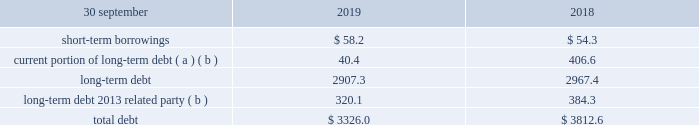During the third quarter ended 30 june 2017 , we recognized a goodwill impairment charge of $ 145.3 and an intangible asset impairment charge of $ 16.8 associated with our lasa reporting unit .
Refer to note 11 , goodwill , and note 12 , intangible assets , for more information related to these charges and the associated fair value measurement methods and significant inputs/assumptions , which were classified as level 3 since unobservable inputs were utilized in the fair value measurements .
16 .
Debt the tables below summarize our outstanding debt at 30 september 2019 and 2018 : total debt .
( a ) fiscal year 2019 includes the current portion of long-term debt owed to a related party of $ 37.8 .
( b ) refer to note 7 , acquisitions , for additional information regarding related party debt .
Short-term borrowings short-term borrowings consisted of bank obligations of $ 58.2 and $ 54.3 at 30 september 2019 and 2018 , respectively .
The weighted average interest rate of short-term borrowings outstanding at 30 september 2019 and 2018 was 3.7% ( 3.7 % ) and 5.0% ( 5.0 % ) , respectively. .
What is the short-term debt as a percent of total debt , in 2019? 
Rationale: it is the short-term debt divided by the total debt , then turned into a percentage .
Computations: (58.2 / 3326.0)
Answer: 0.0175. During the third quarter ended 30 june 2017 , we recognized a goodwill impairment charge of $ 145.3 and an intangible asset impairment charge of $ 16.8 associated with our lasa reporting unit .
Refer to note 11 , goodwill , and note 12 , intangible assets , for more information related to these charges and the associated fair value measurement methods and significant inputs/assumptions , which were classified as level 3 since unobservable inputs were utilized in the fair value measurements .
16 .
Debt the tables below summarize our outstanding debt at 30 september 2019 and 2018 : total debt .
( a ) fiscal year 2019 includes the current portion of long-term debt owed to a related party of $ 37.8 .
( b ) refer to note 7 , acquisitions , for additional information regarding related party debt .
Short-term borrowings short-term borrowings consisted of bank obligations of $ 58.2 and $ 54.3 at 30 september 2019 and 2018 , respectively .
The weighted average interest rate of short-term borrowings outstanding at 30 september 2019 and 2018 was 3.7% ( 3.7 % ) and 5.0% ( 5.0 % ) , respectively. .
What is the short-term debt as a percent of long-term debt , in 2019? 
Rationale: it is the short-term debt divided by the long-term debt ( the sum of both long-term debts ) , then turned into a percentage .
Computations: (58.2 / (2907.3 + 320.1))
Answer: 0.01803. 